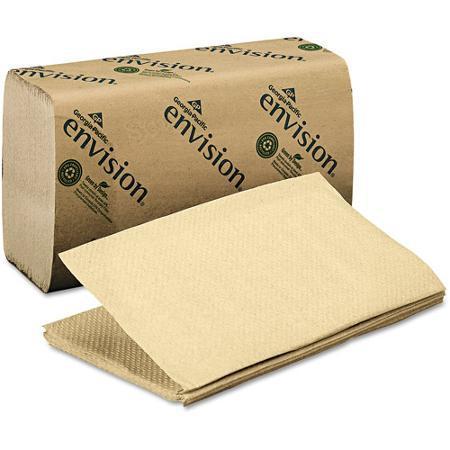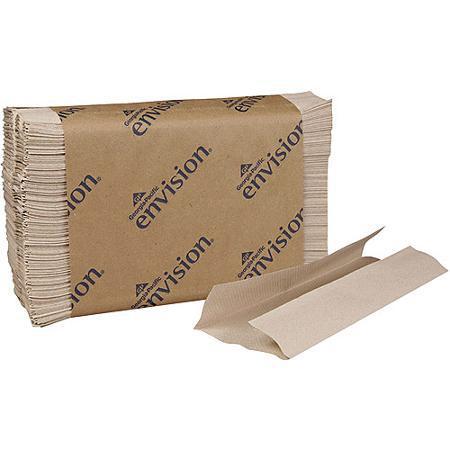The first image is the image on the left, the second image is the image on the right. Given the left and right images, does the statement "The image to the right features brown squares of paper towels." hold true? Answer yes or no. Yes. 